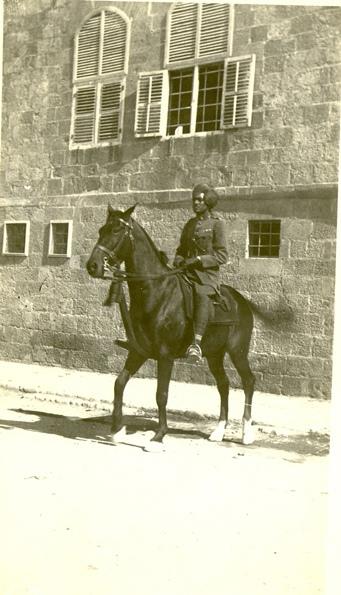Do any of the windows have shutters?
Concise answer only. Yes. Is the horse running?
Give a very brief answer. No. How many doors are on the building?
Quick response, please. 0. 